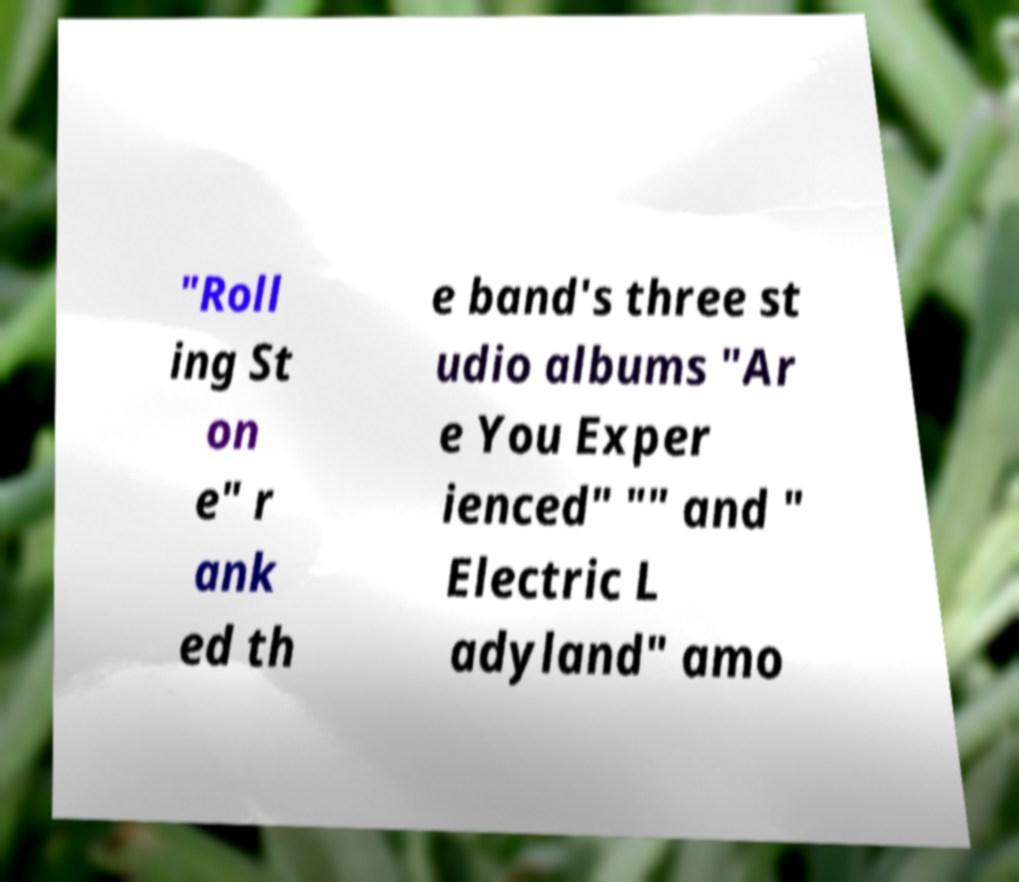What messages or text are displayed in this image? I need them in a readable, typed format. "Roll ing St on e" r ank ed th e band's three st udio albums "Ar e You Exper ienced" "" and " Electric L adyland" amo 